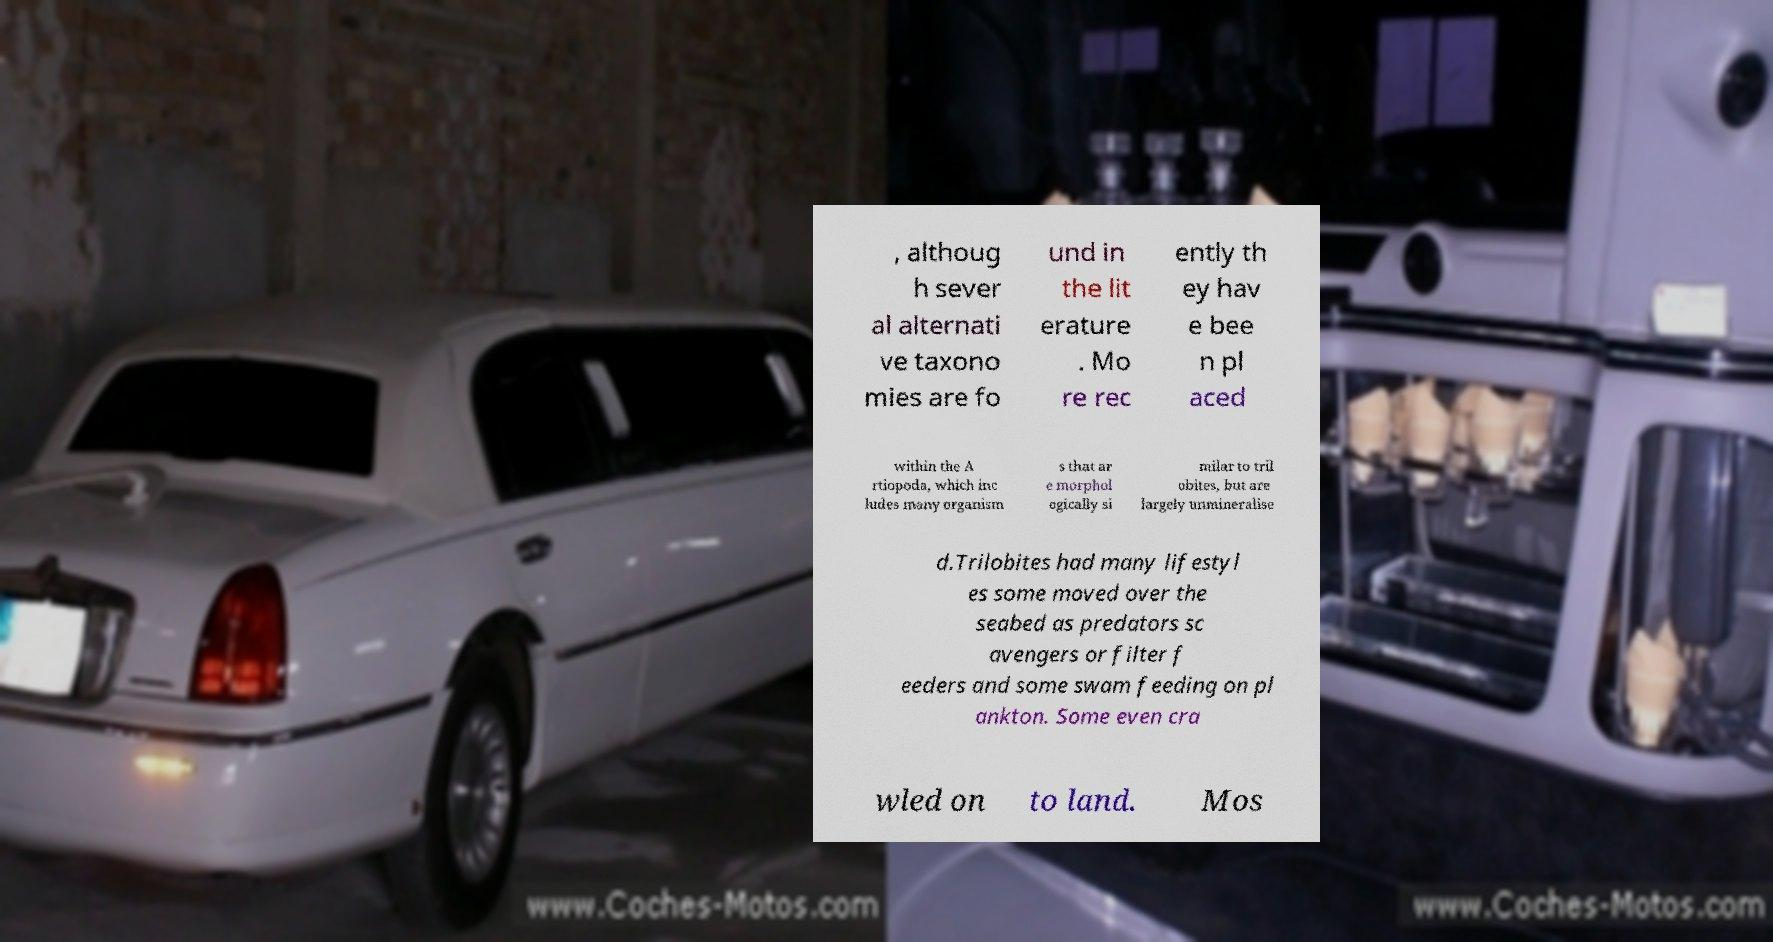Can you accurately transcribe the text from the provided image for me? , althoug h sever al alternati ve taxono mies are fo und in the lit erature . Mo re rec ently th ey hav e bee n pl aced within the A rtiopoda, which inc ludes many organism s that ar e morphol ogically si milar to tril obites, but are largely unmineralise d.Trilobites had many lifestyl es some moved over the seabed as predators sc avengers or filter f eeders and some swam feeding on pl ankton. Some even cra wled on to land. Mos 